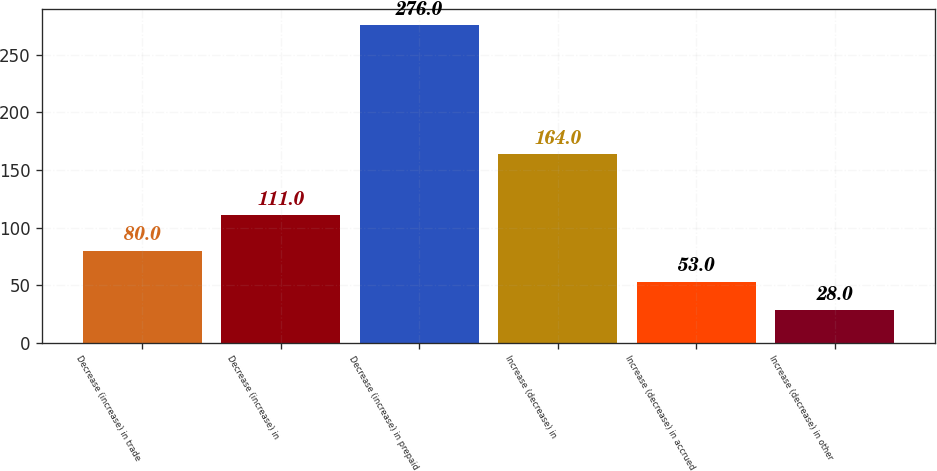<chart> <loc_0><loc_0><loc_500><loc_500><bar_chart><fcel>Decrease (increase) in trade<fcel>Decrease (increase) in<fcel>Decrease (increase) in prepaid<fcel>Increase (decrease) in<fcel>Increase (decrease) in accrued<fcel>Increase (decrease) in other<nl><fcel>80<fcel>111<fcel>276<fcel>164<fcel>53<fcel>28<nl></chart> 